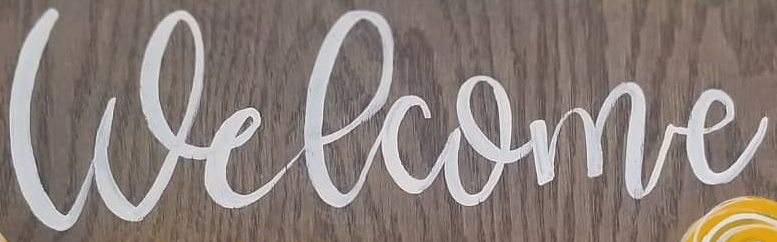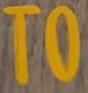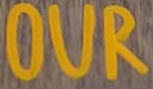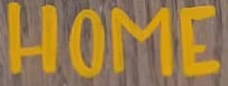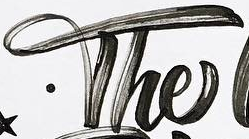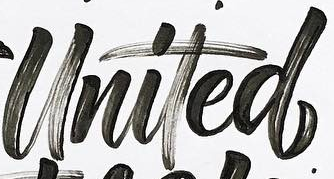What text is displayed in these images sequentially, separated by a semicolon? Welcome; TO; OUR; HOME; The; United 